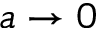Convert formula to latex. <formula><loc_0><loc_0><loc_500><loc_500>a \rightarrow 0</formula> 